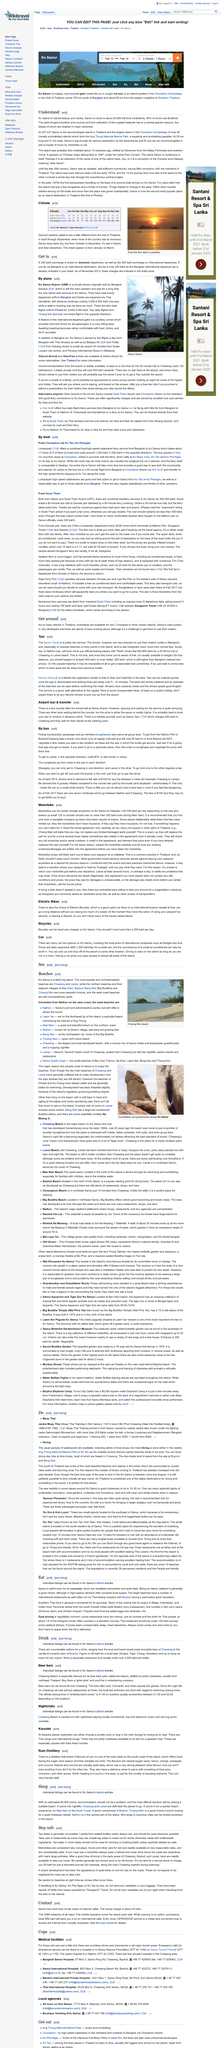Identify some key points in this picture. The beer bars in Chaweng offer a range of activities, including pool, Connect4, and other popular bar games, providing visitors with an enjoyable and engaging experience. I have determined that Lomprayah high speed catamarans are an excellent and fast option for traveling from Ko Tao or Ko Phangan to Samui. The "entertainment zones" close at 01:00, with the closing time typically ranging from 01:00 to 02:00, depending on the location. Samui is the second largest island in Thailand and is home to approximately 40,000 permanent residents. With the exception of motorbikes, a variety of vehicles including Jeeps, trucks, and other cars are available for rent. 